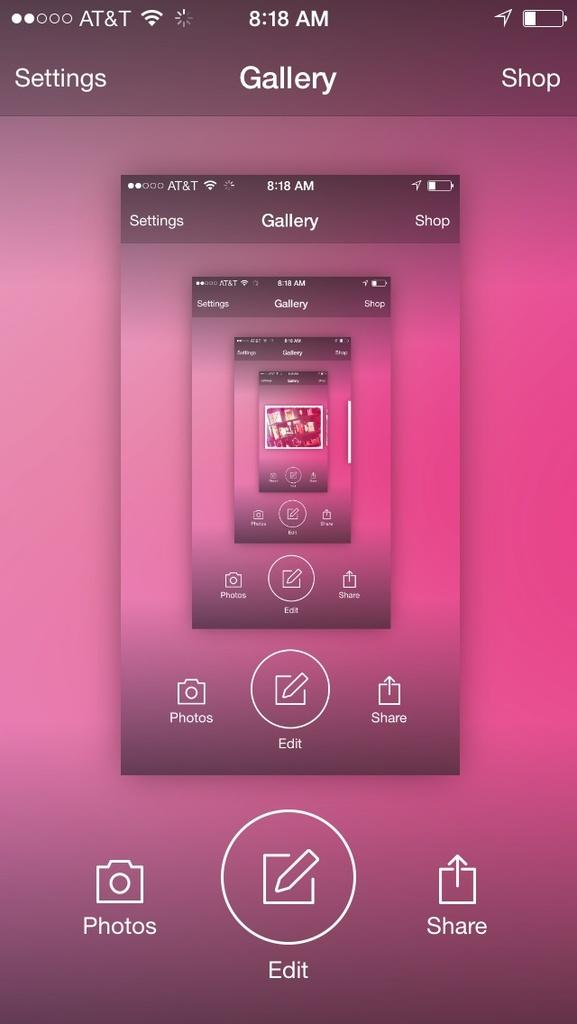<image>
Create a compact narrative representing the image presented. A screenshot from an at&t phone on the gallery page. 